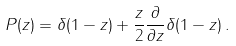<formula> <loc_0><loc_0><loc_500><loc_500>P ( z ) = \delta ( 1 - z ) + \frac { z } { 2 } \frac { \partial } { \partial z } \delta ( 1 - z ) \, .</formula> 